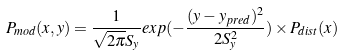Convert formula to latex. <formula><loc_0><loc_0><loc_500><loc_500>P _ { m o d } ( x , y ) = \frac { 1 } { \sqrt { 2 \pi } S _ { y } } e x p ( - \frac { ( y - y _ { p r e d } ) ^ { 2 } } { 2 S _ { y } ^ { 2 } } ) \times P _ { d i s t } ( x )</formula> 